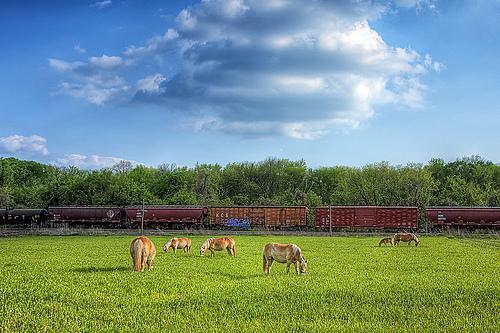How many animals are visible?
Give a very brief answer. 6. How many train cars are visible?
Give a very brief answer. 6. 